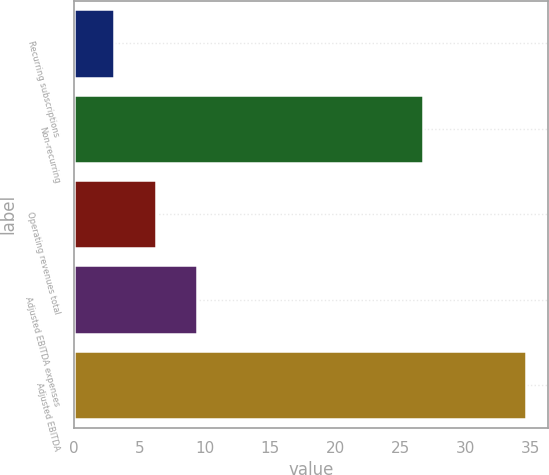Convert chart. <chart><loc_0><loc_0><loc_500><loc_500><bar_chart><fcel>Recurring subscriptions<fcel>Non-recurring<fcel>Operating revenues total<fcel>Adjusted EBITDA expenses<fcel>Adjusted EBITDA<nl><fcel>3.1<fcel>26.7<fcel>6.25<fcel>9.4<fcel>34.6<nl></chart> 